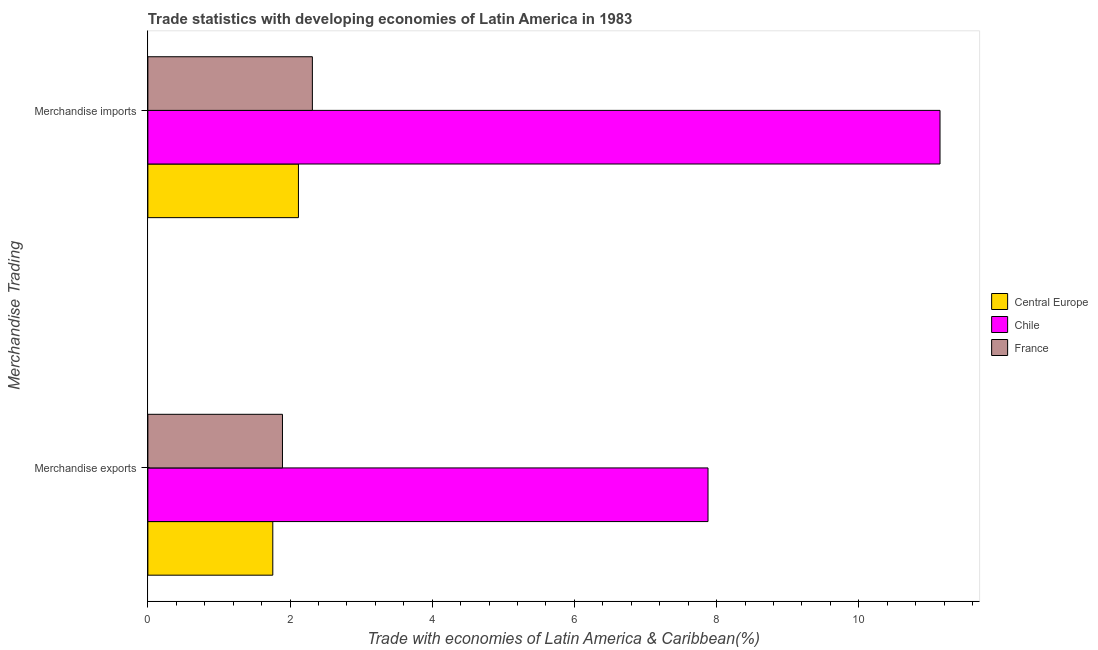Are the number of bars per tick equal to the number of legend labels?
Give a very brief answer. Yes. What is the merchandise imports in France?
Provide a succinct answer. 2.31. Across all countries, what is the maximum merchandise exports?
Offer a terse response. 7.88. Across all countries, what is the minimum merchandise exports?
Give a very brief answer. 1.76. In which country was the merchandise exports maximum?
Your response must be concise. Chile. In which country was the merchandise exports minimum?
Keep it short and to the point. Central Europe. What is the total merchandise exports in the graph?
Ensure brevity in your answer.  11.53. What is the difference between the merchandise exports in Central Europe and that in Chile?
Provide a short and direct response. -6.12. What is the difference between the merchandise imports in Central Europe and the merchandise exports in France?
Provide a succinct answer. 0.22. What is the average merchandise exports per country?
Give a very brief answer. 3.84. What is the difference between the merchandise exports and merchandise imports in France?
Ensure brevity in your answer.  -0.42. What is the ratio of the merchandise imports in France to that in Central Europe?
Make the answer very short. 1.09. In how many countries, is the merchandise exports greater than the average merchandise exports taken over all countries?
Offer a terse response. 1. What does the 1st bar from the top in Merchandise imports represents?
Keep it short and to the point. France. Does the graph contain grids?
Offer a terse response. No. How many legend labels are there?
Your answer should be very brief. 3. How are the legend labels stacked?
Make the answer very short. Vertical. What is the title of the graph?
Your response must be concise. Trade statistics with developing economies of Latin America in 1983. What is the label or title of the X-axis?
Ensure brevity in your answer.  Trade with economies of Latin America & Caribbean(%). What is the label or title of the Y-axis?
Make the answer very short. Merchandise Trading. What is the Trade with economies of Latin America & Caribbean(%) in Central Europe in Merchandise exports?
Make the answer very short. 1.76. What is the Trade with economies of Latin America & Caribbean(%) in Chile in Merchandise exports?
Provide a short and direct response. 7.88. What is the Trade with economies of Latin America & Caribbean(%) of France in Merchandise exports?
Provide a succinct answer. 1.89. What is the Trade with economies of Latin America & Caribbean(%) of Central Europe in Merchandise imports?
Provide a succinct answer. 2.12. What is the Trade with economies of Latin America & Caribbean(%) of Chile in Merchandise imports?
Provide a short and direct response. 11.14. What is the Trade with economies of Latin America & Caribbean(%) in France in Merchandise imports?
Provide a short and direct response. 2.31. Across all Merchandise Trading, what is the maximum Trade with economies of Latin America & Caribbean(%) in Central Europe?
Offer a terse response. 2.12. Across all Merchandise Trading, what is the maximum Trade with economies of Latin America & Caribbean(%) in Chile?
Ensure brevity in your answer.  11.14. Across all Merchandise Trading, what is the maximum Trade with economies of Latin America & Caribbean(%) of France?
Provide a succinct answer. 2.31. Across all Merchandise Trading, what is the minimum Trade with economies of Latin America & Caribbean(%) in Central Europe?
Your answer should be compact. 1.76. Across all Merchandise Trading, what is the minimum Trade with economies of Latin America & Caribbean(%) in Chile?
Offer a terse response. 7.88. Across all Merchandise Trading, what is the minimum Trade with economies of Latin America & Caribbean(%) of France?
Make the answer very short. 1.89. What is the total Trade with economies of Latin America & Caribbean(%) of Central Europe in the graph?
Provide a succinct answer. 3.88. What is the total Trade with economies of Latin America & Caribbean(%) of Chile in the graph?
Your answer should be very brief. 19.02. What is the total Trade with economies of Latin America & Caribbean(%) of France in the graph?
Offer a terse response. 4.21. What is the difference between the Trade with economies of Latin America & Caribbean(%) in Central Europe in Merchandise exports and that in Merchandise imports?
Your answer should be compact. -0.36. What is the difference between the Trade with economies of Latin America & Caribbean(%) of Chile in Merchandise exports and that in Merchandise imports?
Provide a succinct answer. -3.26. What is the difference between the Trade with economies of Latin America & Caribbean(%) in France in Merchandise exports and that in Merchandise imports?
Your response must be concise. -0.42. What is the difference between the Trade with economies of Latin America & Caribbean(%) of Central Europe in Merchandise exports and the Trade with economies of Latin America & Caribbean(%) of Chile in Merchandise imports?
Your response must be concise. -9.39. What is the difference between the Trade with economies of Latin America & Caribbean(%) of Central Europe in Merchandise exports and the Trade with economies of Latin America & Caribbean(%) of France in Merchandise imports?
Make the answer very short. -0.56. What is the difference between the Trade with economies of Latin America & Caribbean(%) in Chile in Merchandise exports and the Trade with economies of Latin America & Caribbean(%) in France in Merchandise imports?
Your answer should be compact. 5.57. What is the average Trade with economies of Latin America & Caribbean(%) of Central Europe per Merchandise Trading?
Your response must be concise. 1.94. What is the average Trade with economies of Latin America & Caribbean(%) in Chile per Merchandise Trading?
Your answer should be compact. 9.51. What is the average Trade with economies of Latin America & Caribbean(%) in France per Merchandise Trading?
Keep it short and to the point. 2.1. What is the difference between the Trade with economies of Latin America & Caribbean(%) in Central Europe and Trade with economies of Latin America & Caribbean(%) in Chile in Merchandise exports?
Provide a succinct answer. -6.12. What is the difference between the Trade with economies of Latin America & Caribbean(%) of Central Europe and Trade with economies of Latin America & Caribbean(%) of France in Merchandise exports?
Provide a short and direct response. -0.14. What is the difference between the Trade with economies of Latin America & Caribbean(%) of Chile and Trade with economies of Latin America & Caribbean(%) of France in Merchandise exports?
Make the answer very short. 5.99. What is the difference between the Trade with economies of Latin America & Caribbean(%) of Central Europe and Trade with economies of Latin America & Caribbean(%) of Chile in Merchandise imports?
Make the answer very short. -9.03. What is the difference between the Trade with economies of Latin America & Caribbean(%) of Central Europe and Trade with economies of Latin America & Caribbean(%) of France in Merchandise imports?
Your response must be concise. -0.2. What is the difference between the Trade with economies of Latin America & Caribbean(%) of Chile and Trade with economies of Latin America & Caribbean(%) of France in Merchandise imports?
Offer a very short reply. 8.83. What is the ratio of the Trade with economies of Latin America & Caribbean(%) of Central Europe in Merchandise exports to that in Merchandise imports?
Your response must be concise. 0.83. What is the ratio of the Trade with economies of Latin America & Caribbean(%) in Chile in Merchandise exports to that in Merchandise imports?
Provide a short and direct response. 0.71. What is the ratio of the Trade with economies of Latin America & Caribbean(%) of France in Merchandise exports to that in Merchandise imports?
Your response must be concise. 0.82. What is the difference between the highest and the second highest Trade with economies of Latin America & Caribbean(%) of Central Europe?
Offer a terse response. 0.36. What is the difference between the highest and the second highest Trade with economies of Latin America & Caribbean(%) in Chile?
Your answer should be compact. 3.26. What is the difference between the highest and the second highest Trade with economies of Latin America & Caribbean(%) in France?
Your answer should be very brief. 0.42. What is the difference between the highest and the lowest Trade with economies of Latin America & Caribbean(%) in Central Europe?
Your response must be concise. 0.36. What is the difference between the highest and the lowest Trade with economies of Latin America & Caribbean(%) in Chile?
Your answer should be compact. 3.26. What is the difference between the highest and the lowest Trade with economies of Latin America & Caribbean(%) of France?
Give a very brief answer. 0.42. 